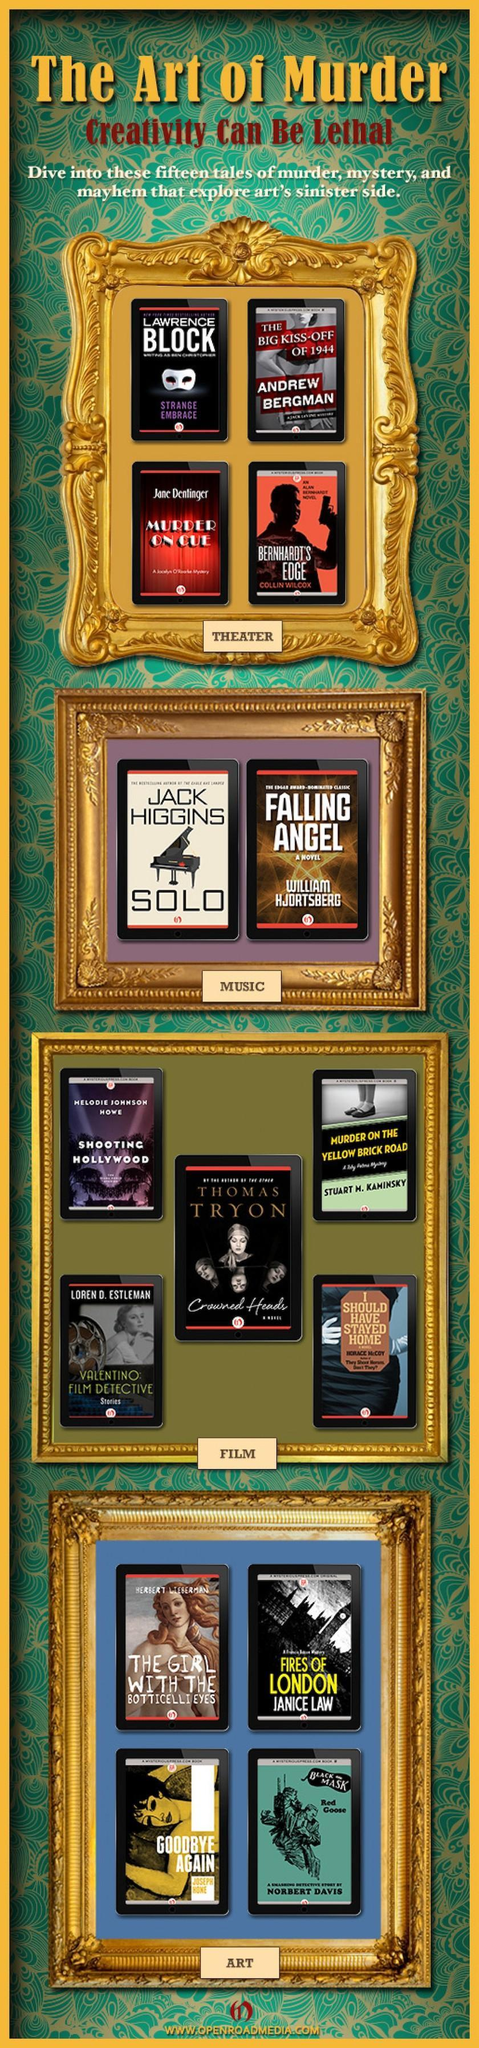How many books have a backdrop theme of movies ?
Answer the question with a short phrase. 5 Which book has an  image of a piano on its cover page? Solo Which book has a white eye mask on its cover page ? Strange Embrace 